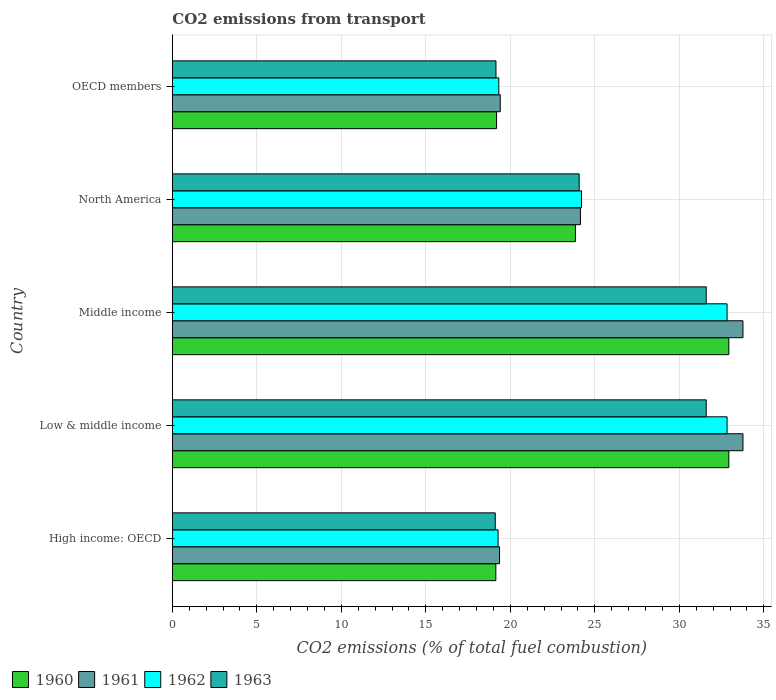How many different coloured bars are there?
Give a very brief answer. 4. Are the number of bars per tick equal to the number of legend labels?
Your answer should be compact. Yes. Are the number of bars on each tick of the Y-axis equal?
Offer a terse response. Yes. How many bars are there on the 3rd tick from the bottom?
Provide a short and direct response. 4. What is the total CO2 emitted in 1961 in Middle income?
Ensure brevity in your answer.  33.76. Across all countries, what is the maximum total CO2 emitted in 1960?
Offer a very short reply. 32.93. Across all countries, what is the minimum total CO2 emitted in 1960?
Your answer should be compact. 19.14. In which country was the total CO2 emitted in 1962 maximum?
Your answer should be very brief. Low & middle income. In which country was the total CO2 emitted in 1960 minimum?
Provide a succinct answer. High income: OECD. What is the total total CO2 emitted in 1960 in the graph?
Give a very brief answer. 128.03. What is the difference between the total CO2 emitted in 1961 in High income: OECD and that in North America?
Ensure brevity in your answer.  -4.79. What is the difference between the total CO2 emitted in 1960 in High income: OECD and the total CO2 emitted in 1962 in Low & middle income?
Give a very brief answer. -13.68. What is the average total CO2 emitted in 1960 per country?
Offer a terse response. 25.61. What is the difference between the total CO2 emitted in 1962 and total CO2 emitted in 1960 in Low & middle income?
Your answer should be compact. -0.1. In how many countries, is the total CO2 emitted in 1961 greater than 13 ?
Your response must be concise. 5. What is the ratio of the total CO2 emitted in 1961 in North America to that in OECD members?
Offer a terse response. 1.24. Is the difference between the total CO2 emitted in 1962 in Low & middle income and North America greater than the difference between the total CO2 emitted in 1960 in Low & middle income and North America?
Keep it short and to the point. No. What is the difference between the highest and the lowest total CO2 emitted in 1960?
Offer a very short reply. 13.79. In how many countries, is the total CO2 emitted in 1960 greater than the average total CO2 emitted in 1960 taken over all countries?
Give a very brief answer. 2. What does the 3rd bar from the top in OECD members represents?
Offer a terse response. 1961. Is it the case that in every country, the sum of the total CO2 emitted in 1962 and total CO2 emitted in 1963 is greater than the total CO2 emitted in 1961?
Your answer should be compact. Yes. How many countries are there in the graph?
Give a very brief answer. 5. Does the graph contain any zero values?
Offer a terse response. No. How many legend labels are there?
Keep it short and to the point. 4. What is the title of the graph?
Ensure brevity in your answer.  CO2 emissions from transport. What is the label or title of the X-axis?
Give a very brief answer. CO2 emissions (% of total fuel combustion). What is the label or title of the Y-axis?
Keep it short and to the point. Country. What is the CO2 emissions (% of total fuel combustion) of 1960 in High income: OECD?
Keep it short and to the point. 19.14. What is the CO2 emissions (% of total fuel combustion) of 1961 in High income: OECD?
Offer a very short reply. 19.36. What is the CO2 emissions (% of total fuel combustion) in 1962 in High income: OECD?
Provide a succinct answer. 19.27. What is the CO2 emissions (% of total fuel combustion) of 1963 in High income: OECD?
Give a very brief answer. 19.11. What is the CO2 emissions (% of total fuel combustion) in 1960 in Low & middle income?
Offer a terse response. 32.93. What is the CO2 emissions (% of total fuel combustion) in 1961 in Low & middle income?
Your answer should be very brief. 33.76. What is the CO2 emissions (% of total fuel combustion) of 1962 in Low & middle income?
Ensure brevity in your answer.  32.82. What is the CO2 emissions (% of total fuel combustion) of 1963 in Low & middle income?
Offer a terse response. 31.59. What is the CO2 emissions (% of total fuel combustion) in 1960 in Middle income?
Keep it short and to the point. 32.93. What is the CO2 emissions (% of total fuel combustion) in 1961 in Middle income?
Offer a very short reply. 33.76. What is the CO2 emissions (% of total fuel combustion) of 1962 in Middle income?
Keep it short and to the point. 32.82. What is the CO2 emissions (% of total fuel combustion) of 1963 in Middle income?
Provide a short and direct response. 31.59. What is the CO2 emissions (% of total fuel combustion) of 1960 in North America?
Your answer should be compact. 23.85. What is the CO2 emissions (% of total fuel combustion) of 1961 in North America?
Make the answer very short. 24.15. What is the CO2 emissions (% of total fuel combustion) in 1962 in North America?
Give a very brief answer. 24.21. What is the CO2 emissions (% of total fuel combustion) in 1963 in North America?
Ensure brevity in your answer.  24.07. What is the CO2 emissions (% of total fuel combustion) of 1960 in OECD members?
Make the answer very short. 19.18. What is the CO2 emissions (% of total fuel combustion) of 1961 in OECD members?
Keep it short and to the point. 19.4. What is the CO2 emissions (% of total fuel combustion) in 1962 in OECD members?
Offer a terse response. 19.32. What is the CO2 emissions (% of total fuel combustion) in 1963 in OECD members?
Ensure brevity in your answer.  19.15. Across all countries, what is the maximum CO2 emissions (% of total fuel combustion) in 1960?
Provide a succinct answer. 32.93. Across all countries, what is the maximum CO2 emissions (% of total fuel combustion) of 1961?
Give a very brief answer. 33.76. Across all countries, what is the maximum CO2 emissions (% of total fuel combustion) in 1962?
Provide a succinct answer. 32.82. Across all countries, what is the maximum CO2 emissions (% of total fuel combustion) in 1963?
Your answer should be very brief. 31.59. Across all countries, what is the minimum CO2 emissions (% of total fuel combustion) in 1960?
Your response must be concise. 19.14. Across all countries, what is the minimum CO2 emissions (% of total fuel combustion) of 1961?
Provide a short and direct response. 19.36. Across all countries, what is the minimum CO2 emissions (% of total fuel combustion) of 1962?
Provide a succinct answer. 19.27. Across all countries, what is the minimum CO2 emissions (% of total fuel combustion) in 1963?
Offer a terse response. 19.11. What is the total CO2 emissions (% of total fuel combustion) of 1960 in the graph?
Your answer should be very brief. 128.03. What is the total CO2 emissions (% of total fuel combustion) of 1961 in the graph?
Make the answer very short. 130.44. What is the total CO2 emissions (% of total fuel combustion) in 1962 in the graph?
Your answer should be compact. 128.45. What is the total CO2 emissions (% of total fuel combustion) in 1963 in the graph?
Your answer should be compact. 125.51. What is the difference between the CO2 emissions (% of total fuel combustion) in 1960 in High income: OECD and that in Low & middle income?
Offer a terse response. -13.79. What is the difference between the CO2 emissions (% of total fuel combustion) of 1961 in High income: OECD and that in Low & middle income?
Offer a terse response. -14.4. What is the difference between the CO2 emissions (% of total fuel combustion) of 1962 in High income: OECD and that in Low & middle income?
Provide a succinct answer. -13.55. What is the difference between the CO2 emissions (% of total fuel combustion) in 1963 in High income: OECD and that in Low & middle income?
Make the answer very short. -12.48. What is the difference between the CO2 emissions (% of total fuel combustion) of 1960 in High income: OECD and that in Middle income?
Provide a short and direct response. -13.79. What is the difference between the CO2 emissions (% of total fuel combustion) in 1961 in High income: OECD and that in Middle income?
Ensure brevity in your answer.  -14.4. What is the difference between the CO2 emissions (% of total fuel combustion) of 1962 in High income: OECD and that in Middle income?
Keep it short and to the point. -13.55. What is the difference between the CO2 emissions (% of total fuel combustion) of 1963 in High income: OECD and that in Middle income?
Provide a succinct answer. -12.48. What is the difference between the CO2 emissions (% of total fuel combustion) in 1960 in High income: OECD and that in North America?
Offer a terse response. -4.71. What is the difference between the CO2 emissions (% of total fuel combustion) in 1961 in High income: OECD and that in North America?
Ensure brevity in your answer.  -4.79. What is the difference between the CO2 emissions (% of total fuel combustion) of 1962 in High income: OECD and that in North America?
Offer a very short reply. -4.94. What is the difference between the CO2 emissions (% of total fuel combustion) of 1963 in High income: OECD and that in North America?
Your response must be concise. -4.96. What is the difference between the CO2 emissions (% of total fuel combustion) of 1960 in High income: OECD and that in OECD members?
Give a very brief answer. -0.04. What is the difference between the CO2 emissions (% of total fuel combustion) in 1961 in High income: OECD and that in OECD members?
Your answer should be very brief. -0.04. What is the difference between the CO2 emissions (% of total fuel combustion) in 1962 in High income: OECD and that in OECD members?
Your response must be concise. -0.04. What is the difference between the CO2 emissions (% of total fuel combustion) in 1963 in High income: OECD and that in OECD members?
Provide a succinct answer. -0.04. What is the difference between the CO2 emissions (% of total fuel combustion) in 1961 in Low & middle income and that in Middle income?
Offer a terse response. 0. What is the difference between the CO2 emissions (% of total fuel combustion) of 1962 in Low & middle income and that in Middle income?
Provide a short and direct response. 0. What is the difference between the CO2 emissions (% of total fuel combustion) of 1963 in Low & middle income and that in Middle income?
Give a very brief answer. 0. What is the difference between the CO2 emissions (% of total fuel combustion) of 1960 in Low & middle income and that in North America?
Keep it short and to the point. 9.08. What is the difference between the CO2 emissions (% of total fuel combustion) of 1961 in Low & middle income and that in North America?
Make the answer very short. 9.62. What is the difference between the CO2 emissions (% of total fuel combustion) of 1962 in Low & middle income and that in North America?
Your response must be concise. 8.61. What is the difference between the CO2 emissions (% of total fuel combustion) in 1963 in Low & middle income and that in North America?
Your answer should be compact. 7.52. What is the difference between the CO2 emissions (% of total fuel combustion) in 1960 in Low & middle income and that in OECD members?
Your answer should be very brief. 13.75. What is the difference between the CO2 emissions (% of total fuel combustion) of 1961 in Low & middle income and that in OECD members?
Provide a short and direct response. 14.36. What is the difference between the CO2 emissions (% of total fuel combustion) in 1962 in Low & middle income and that in OECD members?
Ensure brevity in your answer.  13.51. What is the difference between the CO2 emissions (% of total fuel combustion) in 1963 in Low & middle income and that in OECD members?
Your answer should be very brief. 12.44. What is the difference between the CO2 emissions (% of total fuel combustion) of 1960 in Middle income and that in North America?
Your answer should be very brief. 9.08. What is the difference between the CO2 emissions (% of total fuel combustion) in 1961 in Middle income and that in North America?
Ensure brevity in your answer.  9.62. What is the difference between the CO2 emissions (% of total fuel combustion) in 1962 in Middle income and that in North America?
Offer a terse response. 8.61. What is the difference between the CO2 emissions (% of total fuel combustion) in 1963 in Middle income and that in North America?
Your answer should be compact. 7.52. What is the difference between the CO2 emissions (% of total fuel combustion) of 1960 in Middle income and that in OECD members?
Keep it short and to the point. 13.75. What is the difference between the CO2 emissions (% of total fuel combustion) of 1961 in Middle income and that in OECD members?
Offer a terse response. 14.36. What is the difference between the CO2 emissions (% of total fuel combustion) in 1962 in Middle income and that in OECD members?
Your answer should be very brief. 13.51. What is the difference between the CO2 emissions (% of total fuel combustion) of 1963 in Middle income and that in OECD members?
Offer a very short reply. 12.44. What is the difference between the CO2 emissions (% of total fuel combustion) in 1960 in North America and that in OECD members?
Provide a short and direct response. 4.67. What is the difference between the CO2 emissions (% of total fuel combustion) in 1961 in North America and that in OECD members?
Offer a terse response. 4.74. What is the difference between the CO2 emissions (% of total fuel combustion) of 1962 in North America and that in OECD members?
Keep it short and to the point. 4.89. What is the difference between the CO2 emissions (% of total fuel combustion) of 1963 in North America and that in OECD members?
Make the answer very short. 4.92. What is the difference between the CO2 emissions (% of total fuel combustion) in 1960 in High income: OECD and the CO2 emissions (% of total fuel combustion) in 1961 in Low & middle income?
Give a very brief answer. -14.62. What is the difference between the CO2 emissions (% of total fuel combustion) of 1960 in High income: OECD and the CO2 emissions (% of total fuel combustion) of 1962 in Low & middle income?
Your answer should be very brief. -13.68. What is the difference between the CO2 emissions (% of total fuel combustion) of 1960 in High income: OECD and the CO2 emissions (% of total fuel combustion) of 1963 in Low & middle income?
Your response must be concise. -12.45. What is the difference between the CO2 emissions (% of total fuel combustion) in 1961 in High income: OECD and the CO2 emissions (% of total fuel combustion) in 1962 in Low & middle income?
Your answer should be compact. -13.46. What is the difference between the CO2 emissions (% of total fuel combustion) in 1961 in High income: OECD and the CO2 emissions (% of total fuel combustion) in 1963 in Low & middle income?
Provide a short and direct response. -12.23. What is the difference between the CO2 emissions (% of total fuel combustion) of 1962 in High income: OECD and the CO2 emissions (% of total fuel combustion) of 1963 in Low & middle income?
Ensure brevity in your answer.  -12.32. What is the difference between the CO2 emissions (% of total fuel combustion) of 1960 in High income: OECD and the CO2 emissions (% of total fuel combustion) of 1961 in Middle income?
Provide a succinct answer. -14.62. What is the difference between the CO2 emissions (% of total fuel combustion) of 1960 in High income: OECD and the CO2 emissions (% of total fuel combustion) of 1962 in Middle income?
Offer a very short reply. -13.68. What is the difference between the CO2 emissions (% of total fuel combustion) in 1960 in High income: OECD and the CO2 emissions (% of total fuel combustion) in 1963 in Middle income?
Keep it short and to the point. -12.45. What is the difference between the CO2 emissions (% of total fuel combustion) of 1961 in High income: OECD and the CO2 emissions (% of total fuel combustion) of 1962 in Middle income?
Ensure brevity in your answer.  -13.46. What is the difference between the CO2 emissions (% of total fuel combustion) of 1961 in High income: OECD and the CO2 emissions (% of total fuel combustion) of 1963 in Middle income?
Your response must be concise. -12.23. What is the difference between the CO2 emissions (% of total fuel combustion) of 1962 in High income: OECD and the CO2 emissions (% of total fuel combustion) of 1963 in Middle income?
Your answer should be compact. -12.32. What is the difference between the CO2 emissions (% of total fuel combustion) in 1960 in High income: OECD and the CO2 emissions (% of total fuel combustion) in 1961 in North America?
Provide a succinct answer. -5.01. What is the difference between the CO2 emissions (% of total fuel combustion) in 1960 in High income: OECD and the CO2 emissions (% of total fuel combustion) in 1962 in North America?
Your response must be concise. -5.07. What is the difference between the CO2 emissions (% of total fuel combustion) in 1960 in High income: OECD and the CO2 emissions (% of total fuel combustion) in 1963 in North America?
Offer a terse response. -4.93. What is the difference between the CO2 emissions (% of total fuel combustion) of 1961 in High income: OECD and the CO2 emissions (% of total fuel combustion) of 1962 in North America?
Your answer should be compact. -4.85. What is the difference between the CO2 emissions (% of total fuel combustion) in 1961 in High income: OECD and the CO2 emissions (% of total fuel combustion) in 1963 in North America?
Give a very brief answer. -4.71. What is the difference between the CO2 emissions (% of total fuel combustion) in 1962 in High income: OECD and the CO2 emissions (% of total fuel combustion) in 1963 in North America?
Your answer should be compact. -4.8. What is the difference between the CO2 emissions (% of total fuel combustion) of 1960 in High income: OECD and the CO2 emissions (% of total fuel combustion) of 1961 in OECD members?
Ensure brevity in your answer.  -0.26. What is the difference between the CO2 emissions (% of total fuel combustion) of 1960 in High income: OECD and the CO2 emissions (% of total fuel combustion) of 1962 in OECD members?
Provide a succinct answer. -0.18. What is the difference between the CO2 emissions (% of total fuel combustion) of 1960 in High income: OECD and the CO2 emissions (% of total fuel combustion) of 1963 in OECD members?
Offer a very short reply. -0.01. What is the difference between the CO2 emissions (% of total fuel combustion) in 1961 in High income: OECD and the CO2 emissions (% of total fuel combustion) in 1962 in OECD members?
Offer a very short reply. 0.04. What is the difference between the CO2 emissions (% of total fuel combustion) of 1961 in High income: OECD and the CO2 emissions (% of total fuel combustion) of 1963 in OECD members?
Offer a very short reply. 0.21. What is the difference between the CO2 emissions (% of total fuel combustion) of 1962 in High income: OECD and the CO2 emissions (% of total fuel combustion) of 1963 in OECD members?
Ensure brevity in your answer.  0.13. What is the difference between the CO2 emissions (% of total fuel combustion) of 1960 in Low & middle income and the CO2 emissions (% of total fuel combustion) of 1961 in Middle income?
Your answer should be very brief. -0.84. What is the difference between the CO2 emissions (% of total fuel combustion) of 1960 in Low & middle income and the CO2 emissions (% of total fuel combustion) of 1962 in Middle income?
Your answer should be very brief. 0.1. What is the difference between the CO2 emissions (% of total fuel combustion) in 1960 in Low & middle income and the CO2 emissions (% of total fuel combustion) in 1963 in Middle income?
Keep it short and to the point. 1.34. What is the difference between the CO2 emissions (% of total fuel combustion) in 1961 in Low & middle income and the CO2 emissions (% of total fuel combustion) in 1962 in Middle income?
Make the answer very short. 0.94. What is the difference between the CO2 emissions (% of total fuel combustion) in 1961 in Low & middle income and the CO2 emissions (% of total fuel combustion) in 1963 in Middle income?
Give a very brief answer. 2.17. What is the difference between the CO2 emissions (% of total fuel combustion) of 1962 in Low & middle income and the CO2 emissions (% of total fuel combustion) of 1963 in Middle income?
Offer a very short reply. 1.23. What is the difference between the CO2 emissions (% of total fuel combustion) in 1960 in Low & middle income and the CO2 emissions (% of total fuel combustion) in 1961 in North America?
Give a very brief answer. 8.78. What is the difference between the CO2 emissions (% of total fuel combustion) in 1960 in Low & middle income and the CO2 emissions (% of total fuel combustion) in 1962 in North America?
Give a very brief answer. 8.72. What is the difference between the CO2 emissions (% of total fuel combustion) in 1960 in Low & middle income and the CO2 emissions (% of total fuel combustion) in 1963 in North America?
Your answer should be compact. 8.86. What is the difference between the CO2 emissions (% of total fuel combustion) in 1961 in Low & middle income and the CO2 emissions (% of total fuel combustion) in 1962 in North America?
Provide a short and direct response. 9.55. What is the difference between the CO2 emissions (% of total fuel combustion) of 1961 in Low & middle income and the CO2 emissions (% of total fuel combustion) of 1963 in North America?
Your answer should be very brief. 9.69. What is the difference between the CO2 emissions (% of total fuel combustion) in 1962 in Low & middle income and the CO2 emissions (% of total fuel combustion) in 1963 in North America?
Provide a short and direct response. 8.75. What is the difference between the CO2 emissions (% of total fuel combustion) in 1960 in Low & middle income and the CO2 emissions (% of total fuel combustion) in 1961 in OECD members?
Your response must be concise. 13.53. What is the difference between the CO2 emissions (% of total fuel combustion) of 1960 in Low & middle income and the CO2 emissions (% of total fuel combustion) of 1962 in OECD members?
Your answer should be very brief. 13.61. What is the difference between the CO2 emissions (% of total fuel combustion) of 1960 in Low & middle income and the CO2 emissions (% of total fuel combustion) of 1963 in OECD members?
Offer a very short reply. 13.78. What is the difference between the CO2 emissions (% of total fuel combustion) in 1961 in Low & middle income and the CO2 emissions (% of total fuel combustion) in 1962 in OECD members?
Keep it short and to the point. 14.45. What is the difference between the CO2 emissions (% of total fuel combustion) of 1961 in Low & middle income and the CO2 emissions (% of total fuel combustion) of 1963 in OECD members?
Provide a succinct answer. 14.62. What is the difference between the CO2 emissions (% of total fuel combustion) in 1962 in Low & middle income and the CO2 emissions (% of total fuel combustion) in 1963 in OECD members?
Offer a very short reply. 13.68. What is the difference between the CO2 emissions (% of total fuel combustion) in 1960 in Middle income and the CO2 emissions (% of total fuel combustion) in 1961 in North America?
Offer a very short reply. 8.78. What is the difference between the CO2 emissions (% of total fuel combustion) in 1960 in Middle income and the CO2 emissions (% of total fuel combustion) in 1962 in North America?
Ensure brevity in your answer.  8.72. What is the difference between the CO2 emissions (% of total fuel combustion) of 1960 in Middle income and the CO2 emissions (% of total fuel combustion) of 1963 in North America?
Your answer should be compact. 8.86. What is the difference between the CO2 emissions (% of total fuel combustion) in 1961 in Middle income and the CO2 emissions (% of total fuel combustion) in 1962 in North America?
Offer a terse response. 9.55. What is the difference between the CO2 emissions (% of total fuel combustion) of 1961 in Middle income and the CO2 emissions (% of total fuel combustion) of 1963 in North America?
Keep it short and to the point. 9.69. What is the difference between the CO2 emissions (% of total fuel combustion) in 1962 in Middle income and the CO2 emissions (% of total fuel combustion) in 1963 in North America?
Provide a succinct answer. 8.75. What is the difference between the CO2 emissions (% of total fuel combustion) in 1960 in Middle income and the CO2 emissions (% of total fuel combustion) in 1961 in OECD members?
Offer a terse response. 13.53. What is the difference between the CO2 emissions (% of total fuel combustion) in 1960 in Middle income and the CO2 emissions (% of total fuel combustion) in 1962 in OECD members?
Make the answer very short. 13.61. What is the difference between the CO2 emissions (% of total fuel combustion) in 1960 in Middle income and the CO2 emissions (% of total fuel combustion) in 1963 in OECD members?
Keep it short and to the point. 13.78. What is the difference between the CO2 emissions (% of total fuel combustion) in 1961 in Middle income and the CO2 emissions (% of total fuel combustion) in 1962 in OECD members?
Your answer should be very brief. 14.45. What is the difference between the CO2 emissions (% of total fuel combustion) in 1961 in Middle income and the CO2 emissions (% of total fuel combustion) in 1963 in OECD members?
Offer a very short reply. 14.62. What is the difference between the CO2 emissions (% of total fuel combustion) of 1962 in Middle income and the CO2 emissions (% of total fuel combustion) of 1963 in OECD members?
Your answer should be compact. 13.68. What is the difference between the CO2 emissions (% of total fuel combustion) of 1960 in North America and the CO2 emissions (% of total fuel combustion) of 1961 in OECD members?
Provide a succinct answer. 4.45. What is the difference between the CO2 emissions (% of total fuel combustion) of 1960 in North America and the CO2 emissions (% of total fuel combustion) of 1962 in OECD members?
Provide a succinct answer. 4.53. What is the difference between the CO2 emissions (% of total fuel combustion) of 1960 in North America and the CO2 emissions (% of total fuel combustion) of 1963 in OECD members?
Make the answer very short. 4.7. What is the difference between the CO2 emissions (% of total fuel combustion) of 1961 in North America and the CO2 emissions (% of total fuel combustion) of 1962 in OECD members?
Provide a short and direct response. 4.83. What is the difference between the CO2 emissions (% of total fuel combustion) in 1961 in North America and the CO2 emissions (% of total fuel combustion) in 1963 in OECD members?
Your response must be concise. 5. What is the difference between the CO2 emissions (% of total fuel combustion) in 1962 in North America and the CO2 emissions (% of total fuel combustion) in 1963 in OECD members?
Make the answer very short. 5.06. What is the average CO2 emissions (% of total fuel combustion) in 1960 per country?
Your answer should be compact. 25.61. What is the average CO2 emissions (% of total fuel combustion) of 1961 per country?
Make the answer very short. 26.09. What is the average CO2 emissions (% of total fuel combustion) of 1962 per country?
Your answer should be very brief. 25.69. What is the average CO2 emissions (% of total fuel combustion) in 1963 per country?
Provide a short and direct response. 25.1. What is the difference between the CO2 emissions (% of total fuel combustion) in 1960 and CO2 emissions (% of total fuel combustion) in 1961 in High income: OECD?
Your answer should be very brief. -0.22. What is the difference between the CO2 emissions (% of total fuel combustion) of 1960 and CO2 emissions (% of total fuel combustion) of 1962 in High income: OECD?
Give a very brief answer. -0.13. What is the difference between the CO2 emissions (% of total fuel combustion) of 1960 and CO2 emissions (% of total fuel combustion) of 1963 in High income: OECD?
Your answer should be compact. 0.03. What is the difference between the CO2 emissions (% of total fuel combustion) of 1961 and CO2 emissions (% of total fuel combustion) of 1962 in High income: OECD?
Offer a very short reply. 0.09. What is the difference between the CO2 emissions (% of total fuel combustion) of 1961 and CO2 emissions (% of total fuel combustion) of 1963 in High income: OECD?
Provide a succinct answer. 0.25. What is the difference between the CO2 emissions (% of total fuel combustion) in 1962 and CO2 emissions (% of total fuel combustion) in 1963 in High income: OECD?
Offer a terse response. 0.17. What is the difference between the CO2 emissions (% of total fuel combustion) of 1960 and CO2 emissions (% of total fuel combustion) of 1961 in Low & middle income?
Make the answer very short. -0.84. What is the difference between the CO2 emissions (% of total fuel combustion) in 1960 and CO2 emissions (% of total fuel combustion) in 1962 in Low & middle income?
Offer a terse response. 0.1. What is the difference between the CO2 emissions (% of total fuel combustion) in 1960 and CO2 emissions (% of total fuel combustion) in 1963 in Low & middle income?
Provide a short and direct response. 1.34. What is the difference between the CO2 emissions (% of total fuel combustion) of 1961 and CO2 emissions (% of total fuel combustion) of 1962 in Low & middle income?
Your answer should be compact. 0.94. What is the difference between the CO2 emissions (% of total fuel combustion) of 1961 and CO2 emissions (% of total fuel combustion) of 1963 in Low & middle income?
Your response must be concise. 2.17. What is the difference between the CO2 emissions (% of total fuel combustion) of 1962 and CO2 emissions (% of total fuel combustion) of 1963 in Low & middle income?
Keep it short and to the point. 1.23. What is the difference between the CO2 emissions (% of total fuel combustion) of 1960 and CO2 emissions (% of total fuel combustion) of 1961 in Middle income?
Offer a very short reply. -0.84. What is the difference between the CO2 emissions (% of total fuel combustion) of 1960 and CO2 emissions (% of total fuel combustion) of 1962 in Middle income?
Provide a short and direct response. 0.1. What is the difference between the CO2 emissions (% of total fuel combustion) of 1960 and CO2 emissions (% of total fuel combustion) of 1963 in Middle income?
Offer a very short reply. 1.34. What is the difference between the CO2 emissions (% of total fuel combustion) in 1961 and CO2 emissions (% of total fuel combustion) in 1962 in Middle income?
Offer a terse response. 0.94. What is the difference between the CO2 emissions (% of total fuel combustion) of 1961 and CO2 emissions (% of total fuel combustion) of 1963 in Middle income?
Offer a terse response. 2.17. What is the difference between the CO2 emissions (% of total fuel combustion) of 1962 and CO2 emissions (% of total fuel combustion) of 1963 in Middle income?
Your answer should be compact. 1.23. What is the difference between the CO2 emissions (% of total fuel combustion) in 1960 and CO2 emissions (% of total fuel combustion) in 1961 in North America?
Keep it short and to the point. -0.3. What is the difference between the CO2 emissions (% of total fuel combustion) of 1960 and CO2 emissions (% of total fuel combustion) of 1962 in North America?
Your answer should be compact. -0.36. What is the difference between the CO2 emissions (% of total fuel combustion) in 1960 and CO2 emissions (% of total fuel combustion) in 1963 in North America?
Offer a terse response. -0.22. What is the difference between the CO2 emissions (% of total fuel combustion) in 1961 and CO2 emissions (% of total fuel combustion) in 1962 in North America?
Make the answer very short. -0.06. What is the difference between the CO2 emissions (% of total fuel combustion) in 1961 and CO2 emissions (% of total fuel combustion) in 1963 in North America?
Your answer should be very brief. 0.07. What is the difference between the CO2 emissions (% of total fuel combustion) in 1962 and CO2 emissions (% of total fuel combustion) in 1963 in North America?
Offer a terse response. 0.14. What is the difference between the CO2 emissions (% of total fuel combustion) in 1960 and CO2 emissions (% of total fuel combustion) in 1961 in OECD members?
Provide a short and direct response. -0.22. What is the difference between the CO2 emissions (% of total fuel combustion) of 1960 and CO2 emissions (% of total fuel combustion) of 1962 in OECD members?
Your answer should be compact. -0.13. What is the difference between the CO2 emissions (% of total fuel combustion) of 1960 and CO2 emissions (% of total fuel combustion) of 1963 in OECD members?
Provide a succinct answer. 0.03. What is the difference between the CO2 emissions (% of total fuel combustion) of 1961 and CO2 emissions (% of total fuel combustion) of 1962 in OECD members?
Ensure brevity in your answer.  0.09. What is the difference between the CO2 emissions (% of total fuel combustion) of 1961 and CO2 emissions (% of total fuel combustion) of 1963 in OECD members?
Your answer should be compact. 0.25. What is the difference between the CO2 emissions (% of total fuel combustion) in 1962 and CO2 emissions (% of total fuel combustion) in 1963 in OECD members?
Your answer should be compact. 0.17. What is the ratio of the CO2 emissions (% of total fuel combustion) in 1960 in High income: OECD to that in Low & middle income?
Provide a short and direct response. 0.58. What is the ratio of the CO2 emissions (% of total fuel combustion) of 1961 in High income: OECD to that in Low & middle income?
Your answer should be very brief. 0.57. What is the ratio of the CO2 emissions (% of total fuel combustion) of 1962 in High income: OECD to that in Low & middle income?
Give a very brief answer. 0.59. What is the ratio of the CO2 emissions (% of total fuel combustion) of 1963 in High income: OECD to that in Low & middle income?
Provide a succinct answer. 0.6. What is the ratio of the CO2 emissions (% of total fuel combustion) in 1960 in High income: OECD to that in Middle income?
Provide a short and direct response. 0.58. What is the ratio of the CO2 emissions (% of total fuel combustion) in 1961 in High income: OECD to that in Middle income?
Your response must be concise. 0.57. What is the ratio of the CO2 emissions (% of total fuel combustion) of 1962 in High income: OECD to that in Middle income?
Offer a very short reply. 0.59. What is the ratio of the CO2 emissions (% of total fuel combustion) of 1963 in High income: OECD to that in Middle income?
Keep it short and to the point. 0.6. What is the ratio of the CO2 emissions (% of total fuel combustion) of 1960 in High income: OECD to that in North America?
Give a very brief answer. 0.8. What is the ratio of the CO2 emissions (% of total fuel combustion) of 1961 in High income: OECD to that in North America?
Provide a succinct answer. 0.8. What is the ratio of the CO2 emissions (% of total fuel combustion) in 1962 in High income: OECD to that in North America?
Your answer should be very brief. 0.8. What is the ratio of the CO2 emissions (% of total fuel combustion) in 1963 in High income: OECD to that in North America?
Your answer should be very brief. 0.79. What is the ratio of the CO2 emissions (% of total fuel combustion) in 1960 in High income: OECD to that in OECD members?
Make the answer very short. 1. What is the ratio of the CO2 emissions (% of total fuel combustion) in 1960 in Low & middle income to that in Middle income?
Keep it short and to the point. 1. What is the ratio of the CO2 emissions (% of total fuel combustion) of 1962 in Low & middle income to that in Middle income?
Your answer should be compact. 1. What is the ratio of the CO2 emissions (% of total fuel combustion) of 1963 in Low & middle income to that in Middle income?
Provide a succinct answer. 1. What is the ratio of the CO2 emissions (% of total fuel combustion) in 1960 in Low & middle income to that in North America?
Provide a short and direct response. 1.38. What is the ratio of the CO2 emissions (% of total fuel combustion) of 1961 in Low & middle income to that in North America?
Give a very brief answer. 1.4. What is the ratio of the CO2 emissions (% of total fuel combustion) in 1962 in Low & middle income to that in North America?
Give a very brief answer. 1.36. What is the ratio of the CO2 emissions (% of total fuel combustion) of 1963 in Low & middle income to that in North America?
Your answer should be compact. 1.31. What is the ratio of the CO2 emissions (% of total fuel combustion) in 1960 in Low & middle income to that in OECD members?
Offer a terse response. 1.72. What is the ratio of the CO2 emissions (% of total fuel combustion) of 1961 in Low & middle income to that in OECD members?
Make the answer very short. 1.74. What is the ratio of the CO2 emissions (% of total fuel combustion) of 1962 in Low & middle income to that in OECD members?
Provide a short and direct response. 1.7. What is the ratio of the CO2 emissions (% of total fuel combustion) of 1963 in Low & middle income to that in OECD members?
Your answer should be very brief. 1.65. What is the ratio of the CO2 emissions (% of total fuel combustion) in 1960 in Middle income to that in North America?
Your answer should be compact. 1.38. What is the ratio of the CO2 emissions (% of total fuel combustion) in 1961 in Middle income to that in North America?
Offer a very short reply. 1.4. What is the ratio of the CO2 emissions (% of total fuel combustion) of 1962 in Middle income to that in North America?
Give a very brief answer. 1.36. What is the ratio of the CO2 emissions (% of total fuel combustion) of 1963 in Middle income to that in North America?
Your answer should be very brief. 1.31. What is the ratio of the CO2 emissions (% of total fuel combustion) in 1960 in Middle income to that in OECD members?
Offer a very short reply. 1.72. What is the ratio of the CO2 emissions (% of total fuel combustion) in 1961 in Middle income to that in OECD members?
Give a very brief answer. 1.74. What is the ratio of the CO2 emissions (% of total fuel combustion) of 1962 in Middle income to that in OECD members?
Provide a short and direct response. 1.7. What is the ratio of the CO2 emissions (% of total fuel combustion) in 1963 in Middle income to that in OECD members?
Keep it short and to the point. 1.65. What is the ratio of the CO2 emissions (% of total fuel combustion) of 1960 in North America to that in OECD members?
Give a very brief answer. 1.24. What is the ratio of the CO2 emissions (% of total fuel combustion) of 1961 in North America to that in OECD members?
Keep it short and to the point. 1.24. What is the ratio of the CO2 emissions (% of total fuel combustion) in 1962 in North America to that in OECD members?
Your answer should be very brief. 1.25. What is the ratio of the CO2 emissions (% of total fuel combustion) in 1963 in North America to that in OECD members?
Provide a succinct answer. 1.26. What is the difference between the highest and the second highest CO2 emissions (% of total fuel combustion) in 1960?
Your answer should be very brief. 0. What is the difference between the highest and the second highest CO2 emissions (% of total fuel combustion) of 1962?
Provide a succinct answer. 0. What is the difference between the highest and the second highest CO2 emissions (% of total fuel combustion) of 1963?
Ensure brevity in your answer.  0. What is the difference between the highest and the lowest CO2 emissions (% of total fuel combustion) in 1960?
Provide a succinct answer. 13.79. What is the difference between the highest and the lowest CO2 emissions (% of total fuel combustion) in 1961?
Keep it short and to the point. 14.4. What is the difference between the highest and the lowest CO2 emissions (% of total fuel combustion) in 1962?
Your answer should be compact. 13.55. What is the difference between the highest and the lowest CO2 emissions (% of total fuel combustion) in 1963?
Your answer should be compact. 12.48. 